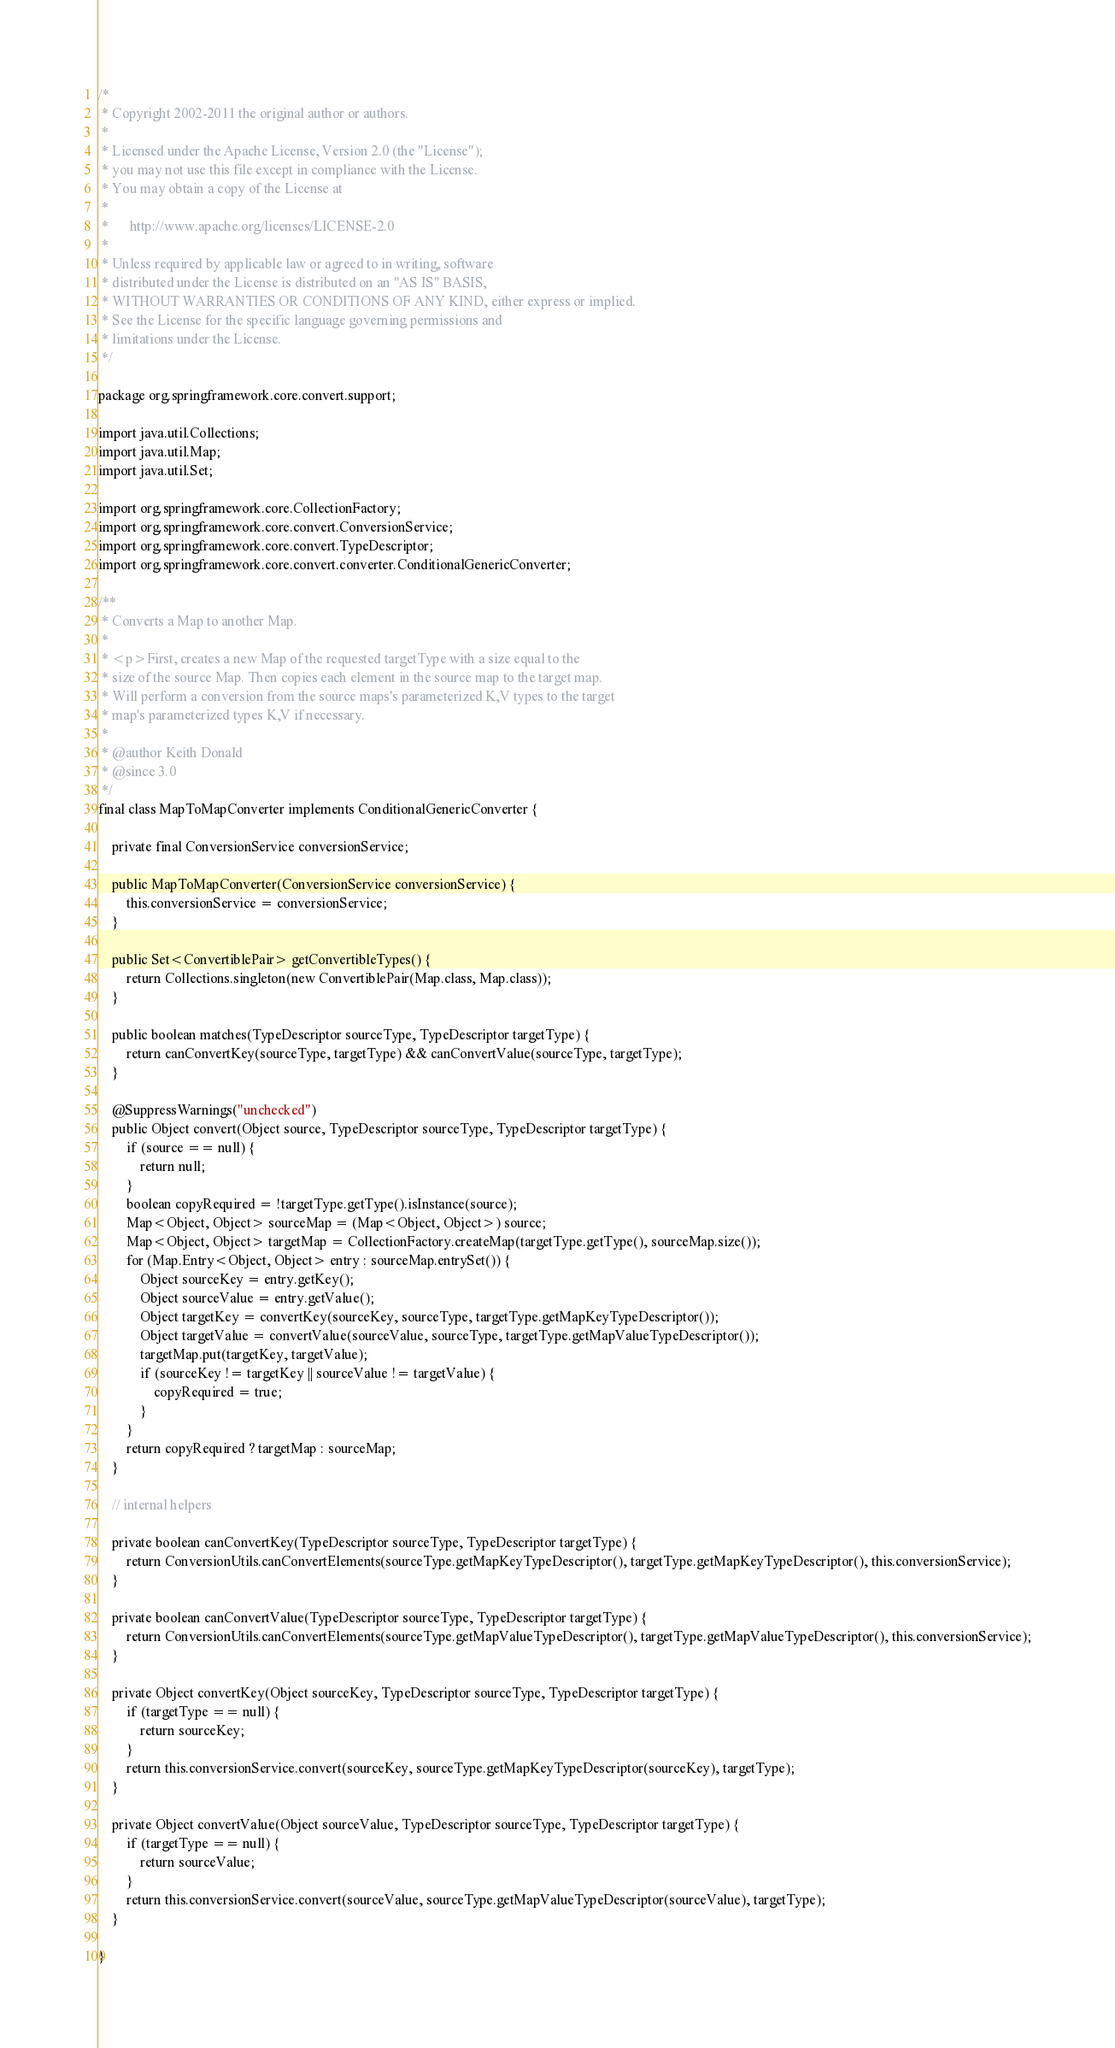Convert code to text. <code><loc_0><loc_0><loc_500><loc_500><_Java_>/*
 * Copyright 2002-2011 the original author or authors.
 *
 * Licensed under the Apache License, Version 2.0 (the "License");
 * you may not use this file except in compliance with the License.
 * You may obtain a copy of the License at
 *
 *      http://www.apache.org/licenses/LICENSE-2.0
 *
 * Unless required by applicable law or agreed to in writing, software
 * distributed under the License is distributed on an "AS IS" BASIS,
 * WITHOUT WARRANTIES OR CONDITIONS OF ANY KIND, either express or implied.
 * See the License for the specific language governing permissions and
 * limitations under the License.
 */

package org.springframework.core.convert.support;

import java.util.Collections;
import java.util.Map;
import java.util.Set;

import org.springframework.core.CollectionFactory;
import org.springframework.core.convert.ConversionService;
import org.springframework.core.convert.TypeDescriptor;
import org.springframework.core.convert.converter.ConditionalGenericConverter;

/**
 * Converts a Map to another Map.
 *
 * <p>First, creates a new Map of the requested targetType with a size equal to the
 * size of the source Map. Then copies each element in the source map to the target map.
 * Will perform a conversion from the source maps's parameterized K,V types to the target
 * map's parameterized types K,V if necessary.
 *
 * @author Keith Donald
 * @since 3.0
 */
final class MapToMapConverter implements ConditionalGenericConverter {

	private final ConversionService conversionService;

	public MapToMapConverter(ConversionService conversionService) {
		this.conversionService = conversionService;
	}

	public Set<ConvertiblePair> getConvertibleTypes() {
		return Collections.singleton(new ConvertiblePair(Map.class, Map.class));
	}

	public boolean matches(TypeDescriptor sourceType, TypeDescriptor targetType) {
		return canConvertKey(sourceType, targetType) && canConvertValue(sourceType, targetType);
	}
	
	@SuppressWarnings("unchecked")
	public Object convert(Object source, TypeDescriptor sourceType, TypeDescriptor targetType) {
		if (source == null) {
			return null;
		}
		boolean copyRequired = !targetType.getType().isInstance(source);
		Map<Object, Object> sourceMap = (Map<Object, Object>) source;
		Map<Object, Object> targetMap = CollectionFactory.createMap(targetType.getType(), sourceMap.size());
		for (Map.Entry<Object, Object> entry : sourceMap.entrySet()) {
			Object sourceKey = entry.getKey();
			Object sourceValue = entry.getValue();
			Object targetKey = convertKey(sourceKey, sourceType, targetType.getMapKeyTypeDescriptor());
			Object targetValue = convertValue(sourceValue, sourceType, targetType.getMapValueTypeDescriptor());
			targetMap.put(targetKey, targetValue);
			if (sourceKey != targetKey || sourceValue != targetValue) {
				copyRequired = true;
			}
		}
		return copyRequired ? targetMap : sourceMap;
	}
	
	// internal helpers

	private boolean canConvertKey(TypeDescriptor sourceType, TypeDescriptor targetType) {
		return ConversionUtils.canConvertElements(sourceType.getMapKeyTypeDescriptor(), targetType.getMapKeyTypeDescriptor(), this.conversionService);
	}
	
	private boolean canConvertValue(TypeDescriptor sourceType, TypeDescriptor targetType) {
		return ConversionUtils.canConvertElements(sourceType.getMapValueTypeDescriptor(), targetType.getMapValueTypeDescriptor(), this.conversionService);
	}
	
	private Object convertKey(Object sourceKey, TypeDescriptor sourceType, TypeDescriptor targetType) {
		if (targetType == null) {
			return sourceKey;
		}
		return this.conversionService.convert(sourceKey, sourceType.getMapKeyTypeDescriptor(sourceKey), targetType);
	}

	private Object convertValue(Object sourceValue, TypeDescriptor sourceType, TypeDescriptor targetType) {
		if (targetType == null) {
			return sourceValue;
		}
		return this.conversionService.convert(sourceValue, sourceType.getMapValueTypeDescriptor(sourceValue), targetType);
	}

}
</code> 